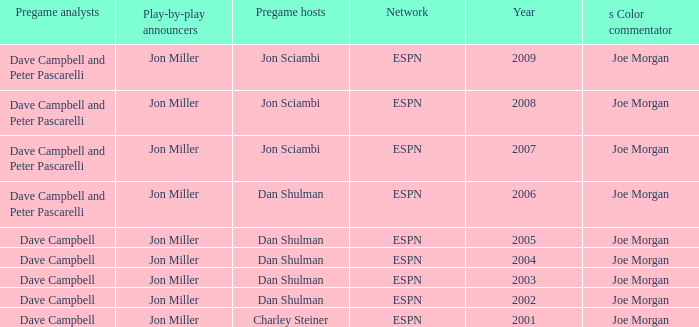Who is the pregame host when the pregame analysts is  Dave Campbell and the year is 2001? Charley Steiner. 